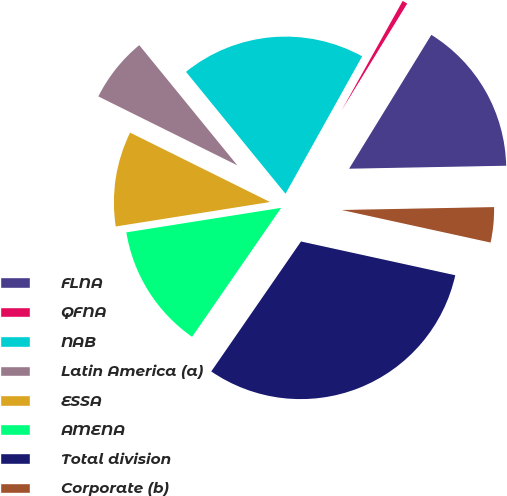Convert chart to OTSL. <chart><loc_0><loc_0><loc_500><loc_500><pie_chart><fcel>FLNA<fcel>QFNA<fcel>NAB<fcel>Latin America (a)<fcel>ESSA<fcel>AMENA<fcel>Total division<fcel>Corporate (b)<nl><fcel>15.93%<fcel>0.67%<fcel>18.99%<fcel>6.78%<fcel>9.83%<fcel>12.88%<fcel>31.19%<fcel>3.73%<nl></chart> 